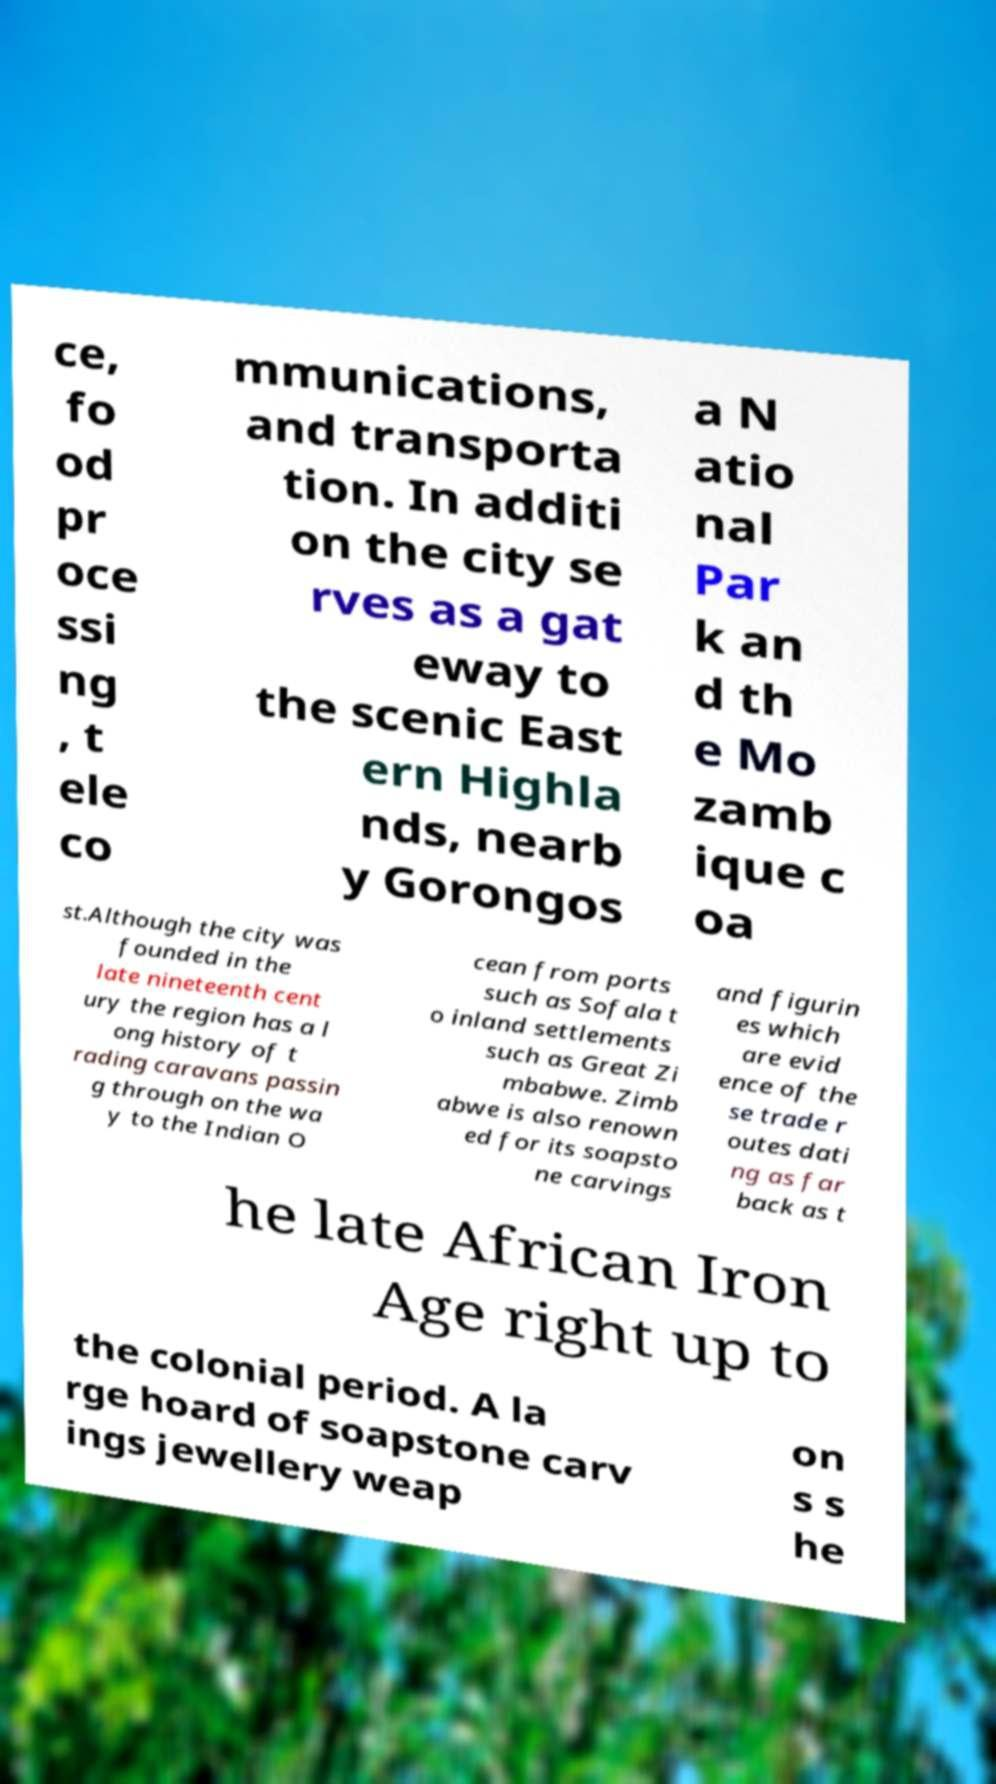Can you accurately transcribe the text from the provided image for me? ce, fo od pr oce ssi ng , t ele co mmunications, and transporta tion. In additi on the city se rves as a gat eway to the scenic East ern Highla nds, nearb y Gorongos a N atio nal Par k an d th e Mo zamb ique c oa st.Although the city was founded in the late nineteenth cent ury the region has a l ong history of t rading caravans passin g through on the wa y to the Indian O cean from ports such as Sofala t o inland settlements such as Great Zi mbabwe. Zimb abwe is also renown ed for its soapsto ne carvings and figurin es which are evid ence of the se trade r outes dati ng as far back as t he late African Iron Age right up to the colonial period. A la rge hoard of soapstone carv ings jewellery weap on s s he 